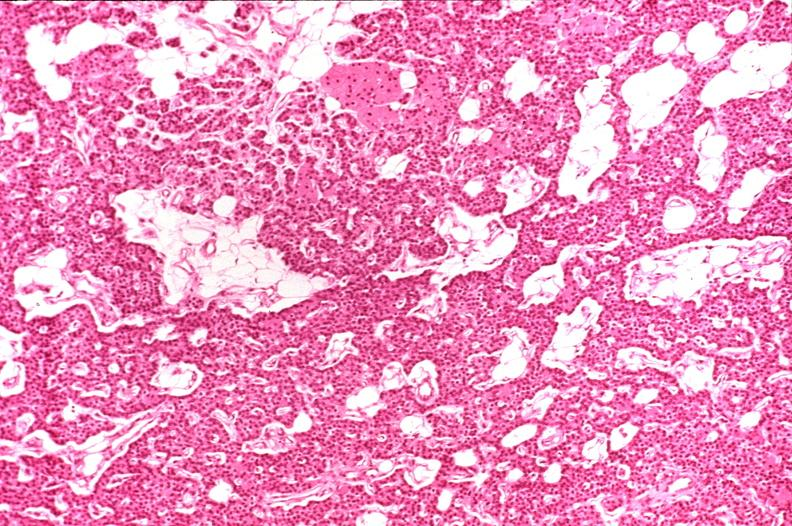does this image show parathyroid, normal?
Answer the question using a single word or phrase. Yes 